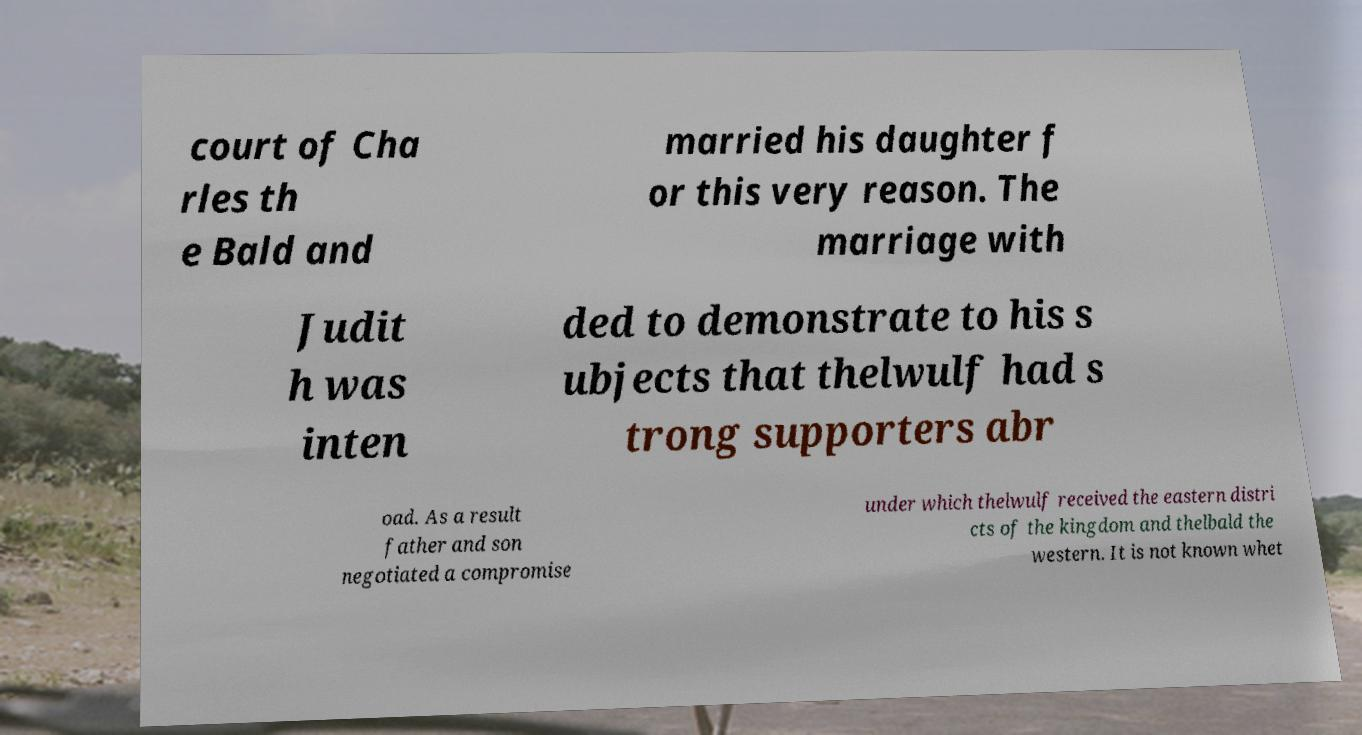Please read and relay the text visible in this image. What does it say? court of Cha rles th e Bald and married his daughter f or this very reason. The marriage with Judit h was inten ded to demonstrate to his s ubjects that thelwulf had s trong supporters abr oad. As a result father and son negotiated a compromise under which thelwulf received the eastern distri cts of the kingdom and thelbald the western. It is not known whet 